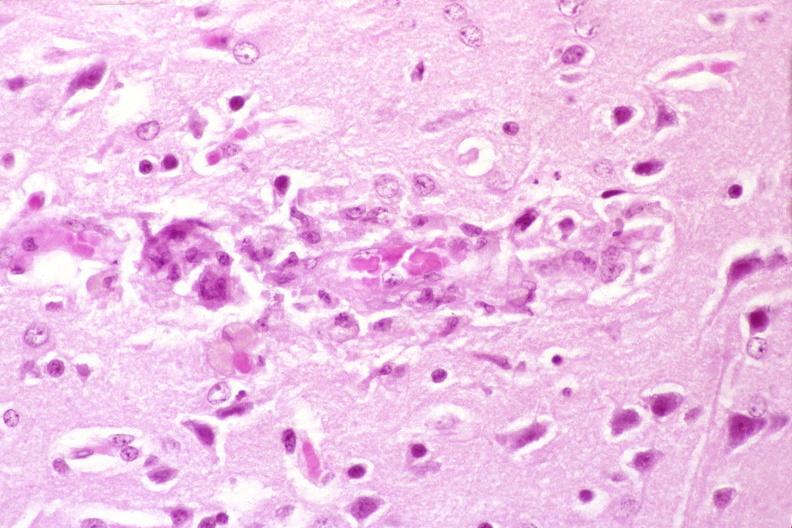s krukenberg tumor present?
Answer the question using a single word or phrase. No 